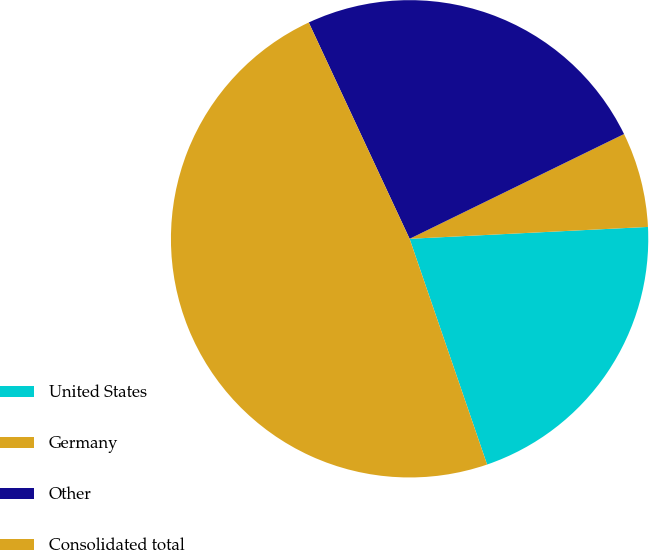Convert chart. <chart><loc_0><loc_0><loc_500><loc_500><pie_chart><fcel>United States<fcel>Germany<fcel>Other<fcel>Consolidated total<nl><fcel>20.53%<fcel>6.44%<fcel>24.71%<fcel>48.32%<nl></chart> 